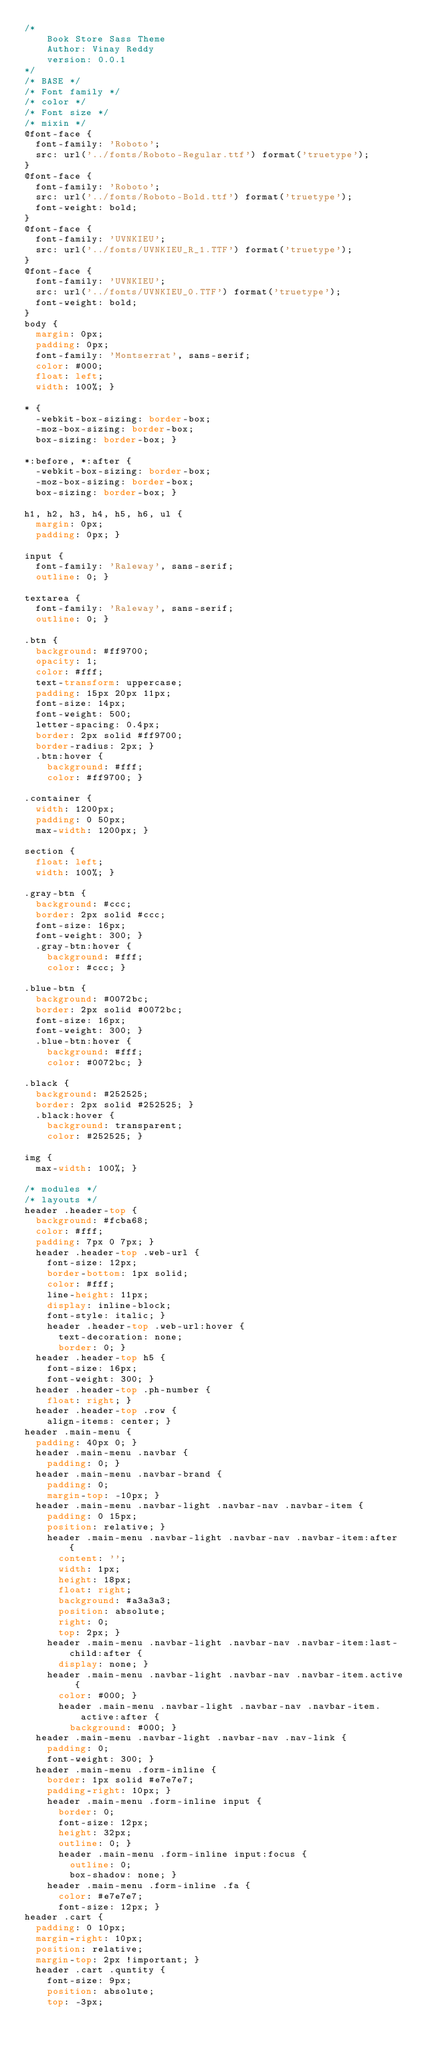<code> <loc_0><loc_0><loc_500><loc_500><_CSS_>/*
	Book Store Sass Theme
	Author: Vinay Reddy
	version: 0.0.1
*/
/* BASE */
/* Font family */
/* color */
/* Font size */
/* mixin */
@font-face {
  font-family: 'Roboto';
  src: url('../fonts/Roboto-Regular.ttf') format('truetype');
}
@font-face {
  font-family: 'Roboto';
  src: url('../fonts/Roboto-Bold.ttf') format('truetype');
  font-weight: bold;
}
@font-face {
  font-family: 'UVNKIEU';
  src: url('../fonts/UVNKIEU_R_1.TTF') format('truetype');
}
@font-face {
  font-family: 'UVNKIEU';
  src: url('../fonts/UVNKIEU_0.TTF') format('truetype');
  font-weight: bold;
}
body {
  margin: 0px;
  padding: 0px;
  font-family: 'Montserrat', sans-serif;
  color: #000;
  float: left;
  width: 100%; }

* {
  -webkit-box-sizing: border-box;
  -moz-box-sizing: border-box;
  box-sizing: border-box; }

*:before, *:after {
  -webkit-box-sizing: border-box;
  -moz-box-sizing: border-box;
  box-sizing: border-box; }

h1, h2, h3, h4, h5, h6, ul {
  margin: 0px;
  padding: 0px; }

input {
  font-family: 'Raleway', sans-serif;
  outline: 0; }

textarea {
  font-family: 'Raleway', sans-serif;
  outline: 0; }

.btn {
  background: #ff9700;
  opacity: 1;
  color: #fff;
  text-transform: uppercase;
  padding: 15px 20px 11px;
  font-size: 14px;
  font-weight: 500;
  letter-spacing: 0.4px;
  border: 2px solid #ff9700;
  border-radius: 2px; }
  .btn:hover {
    background: #fff;
    color: #ff9700; }

.container {
  width: 1200px;
  padding: 0 50px;
  max-width: 1200px; }

section {
  float: left;
  width: 100%; }

.gray-btn {
  background: #ccc;
  border: 2px solid #ccc;
  font-size: 16px;
  font-weight: 300; }
  .gray-btn:hover {
    background: #fff;
    color: #ccc; }

.blue-btn {
  background: #0072bc;
  border: 2px solid #0072bc;
  font-size: 16px;
  font-weight: 300; }
  .blue-btn:hover {
    background: #fff;
    color: #0072bc; }

.black {
  background: #252525;
  border: 2px solid #252525; }
  .black:hover {
    background: transparent;
    color: #252525; }

img {
  max-width: 100%; }

/* modules */
/* layouts */
header .header-top {
  background: #fcba68;
  color: #fff;
  padding: 7px 0 7px; }
  header .header-top .web-url {
    font-size: 12px;
    border-bottom: 1px solid;
    color: #fff;
    line-height: 11px;
    display: inline-block;
    font-style: italic; }
    header .header-top .web-url:hover {
      text-decoration: none;
      border: 0; }
  header .header-top h5 {
    font-size: 16px;
    font-weight: 300; }
  header .header-top .ph-number {
    float: right; }
  header .header-top .row {
    align-items: center; }
header .main-menu {
  padding: 40px 0; }
  header .main-menu .navbar {
    padding: 0; }
  header .main-menu .navbar-brand {
    padding: 0;
    margin-top: -10px; }
  header .main-menu .navbar-light .navbar-nav .navbar-item {
    padding: 0 15px;
    position: relative; }
    header .main-menu .navbar-light .navbar-nav .navbar-item:after {
      content: '';
      width: 1px;
      height: 18px;
      float: right;
      background: #a3a3a3;
      position: absolute;
      right: 0;
      top: 2px; }
    header .main-menu .navbar-light .navbar-nav .navbar-item:last-child:after {
      display: none; }
    header .main-menu .navbar-light .navbar-nav .navbar-item.active {
      color: #000; }
      header .main-menu .navbar-light .navbar-nav .navbar-item.active:after {
        background: #000; }
  header .main-menu .navbar-light .navbar-nav .nav-link {
    padding: 0;
    font-weight: 300; }
  header .main-menu .form-inline {
    border: 1px solid #e7e7e7;
    padding-right: 10px; }
    header .main-menu .form-inline input {
      border: 0;
      font-size: 12px;
      height: 32px;
      outline: 0; }
      header .main-menu .form-inline input:focus {
        outline: 0;
        box-shadow: none; }
    header .main-menu .form-inline .fa {
      color: #e7e7e7;
      font-size: 12px; }
header .cart {
  padding: 0 10px;
  margin-right: 10px;
  position: relative;
  margin-top: 2px !important; }
  header .cart .quntity {
    font-size: 9px;
    position: absolute;
    top: -3px;</code> 